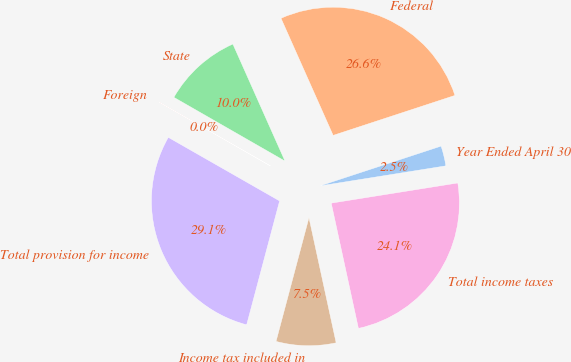<chart> <loc_0><loc_0><loc_500><loc_500><pie_chart><fcel>Year Ended April 30<fcel>Federal<fcel>State<fcel>Foreign<fcel>Total provision for income<fcel>Income tax included in<fcel>Total income taxes<nl><fcel>2.53%<fcel>26.62%<fcel>10.04%<fcel>0.03%<fcel>29.12%<fcel>7.54%<fcel>24.11%<nl></chart> 